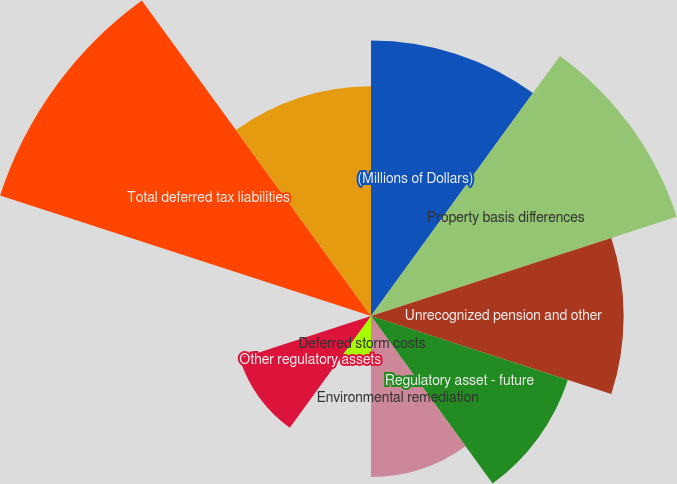Convert chart to OTSL. <chart><loc_0><loc_0><loc_500><loc_500><pie_chart><fcel>(Millions of Dollars)<fcel>Property basis differences<fcel>Unrecognized pension and other<fcel>Regulatory asset - future<fcel>Environmental remediation<fcel>Deferred storm costs<fcel>Other regulatory assets<fcel>Unamortized investment tax<fcel>Total deferred tax liabilities<fcel>Accrued pension and other<nl><fcel>13.62%<fcel>15.89%<fcel>12.49%<fcel>10.23%<fcel>7.96%<fcel>2.3%<fcel>6.83%<fcel>0.04%<fcel>19.28%<fcel>11.36%<nl></chart> 